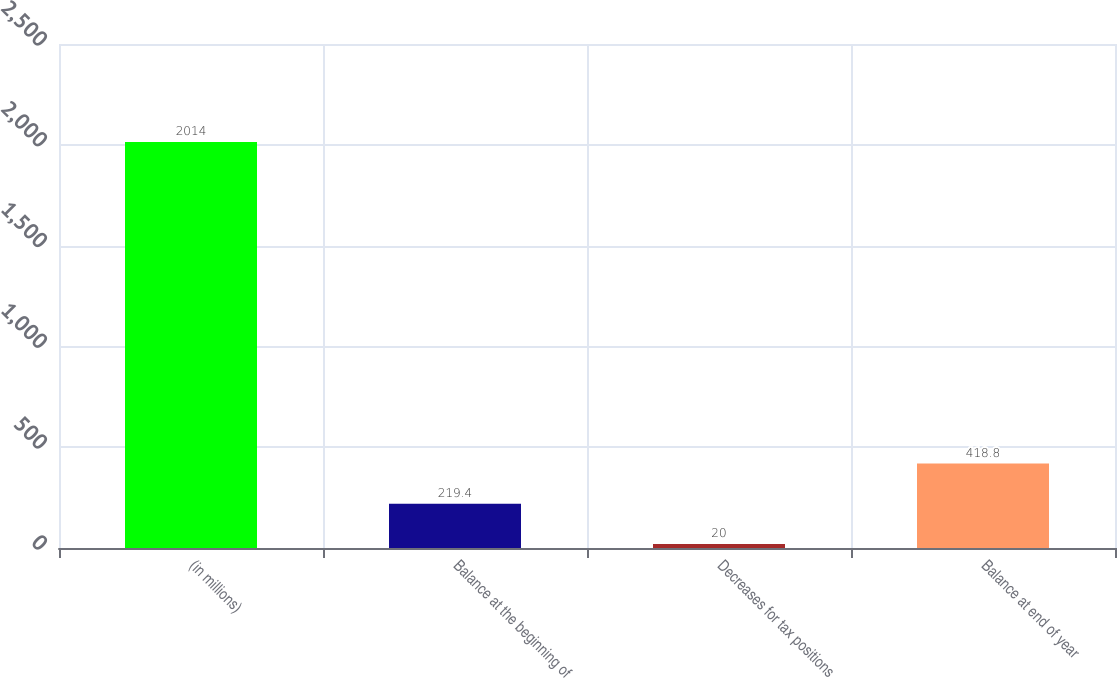Convert chart to OTSL. <chart><loc_0><loc_0><loc_500><loc_500><bar_chart><fcel>(in millions)<fcel>Balance at the beginning of<fcel>Decreases for tax positions<fcel>Balance at end of year<nl><fcel>2014<fcel>219.4<fcel>20<fcel>418.8<nl></chart> 